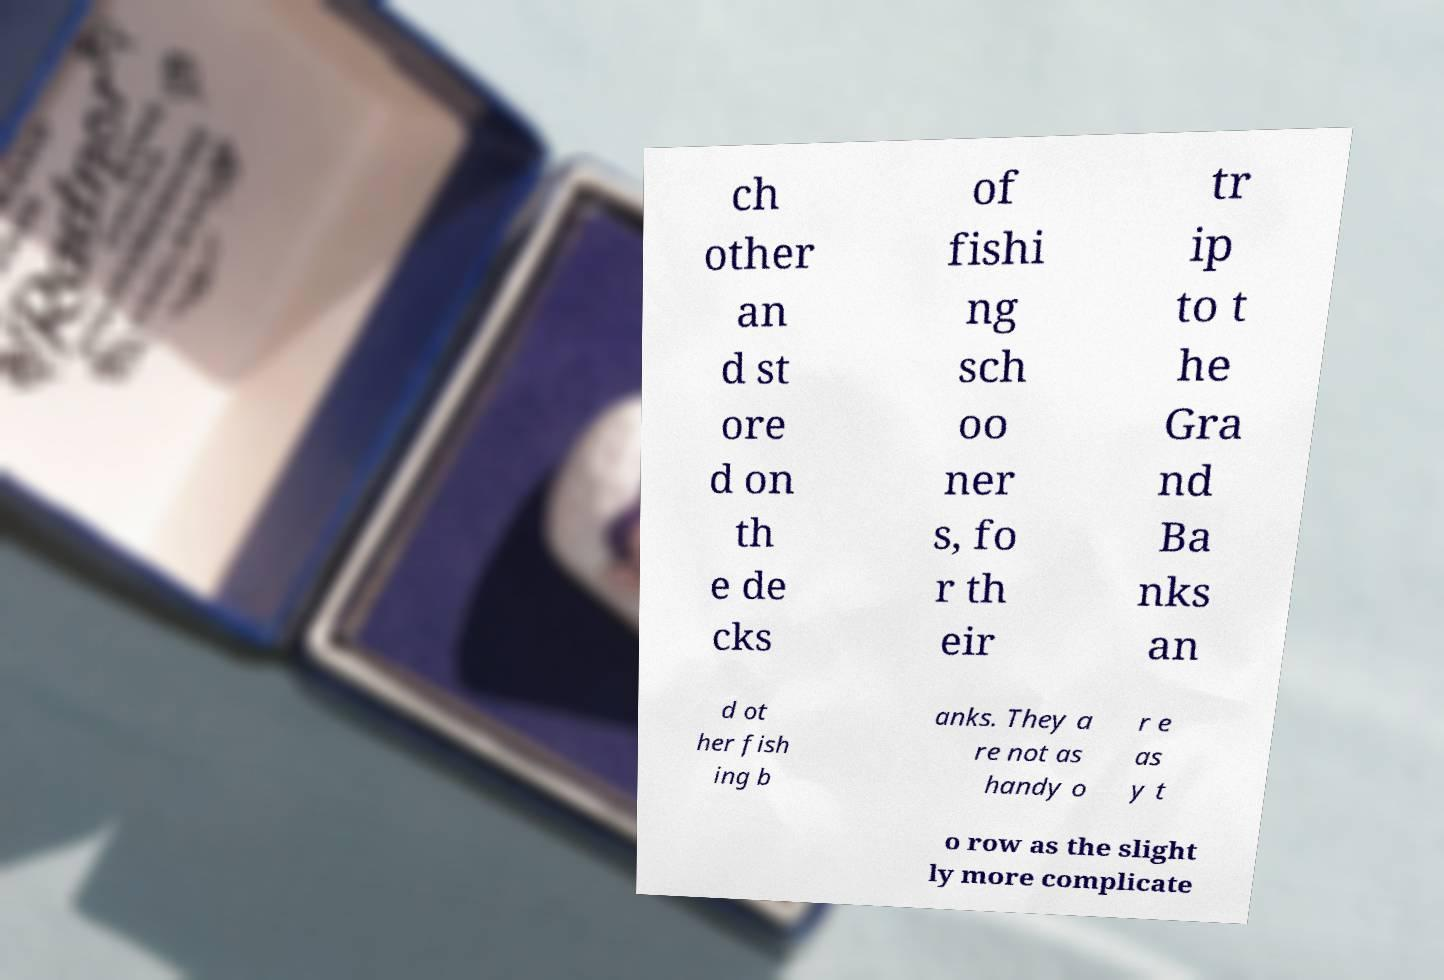There's text embedded in this image that I need extracted. Can you transcribe it verbatim? ch other an d st ore d on th e de cks of fishi ng sch oo ner s, fo r th eir tr ip to t he Gra nd Ba nks an d ot her fish ing b anks. They a re not as handy o r e as y t o row as the slight ly more complicate 